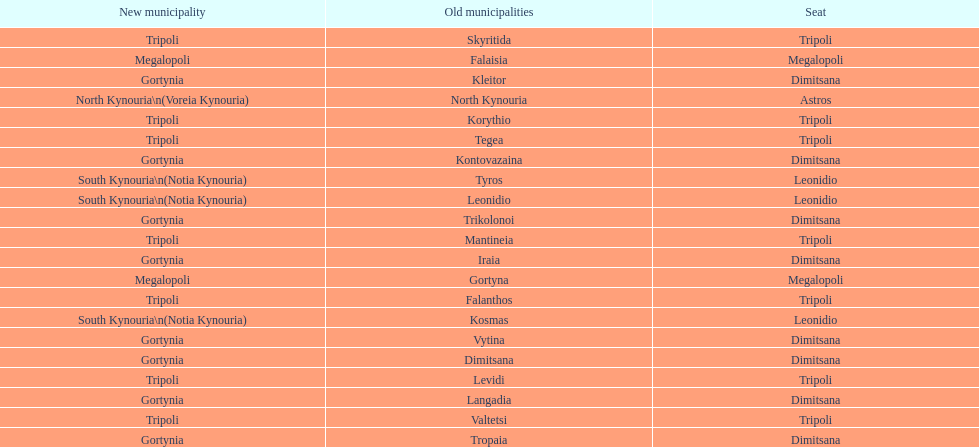Is tripoli still considered a municipality in arcadia since its 2011 reformation? Yes. 